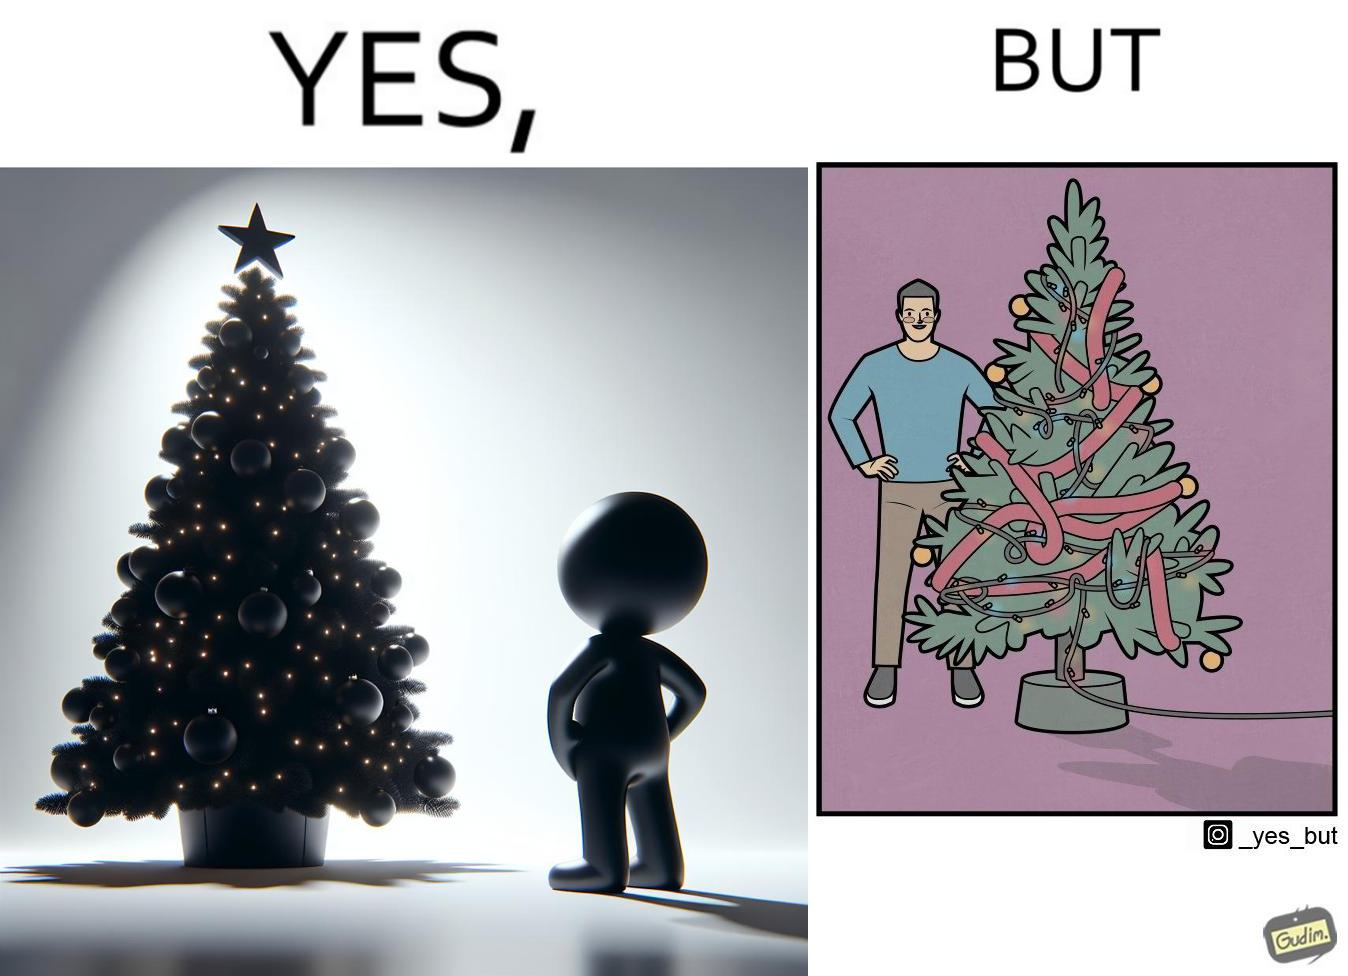Is there satirical content in this image? Yes, this image is satirical. 